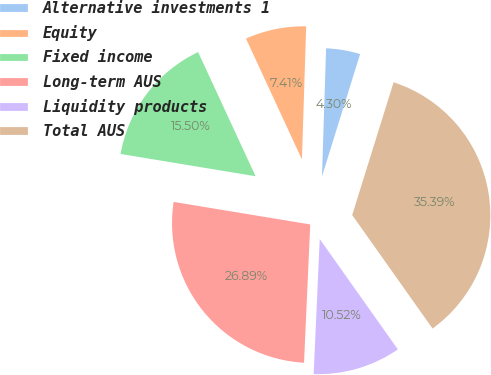Convert chart to OTSL. <chart><loc_0><loc_0><loc_500><loc_500><pie_chart><fcel>Alternative investments 1<fcel>Equity<fcel>Fixed income<fcel>Long-term AUS<fcel>Liquidity products<fcel>Total AUS<nl><fcel>4.3%<fcel>7.41%<fcel>15.5%<fcel>26.89%<fcel>10.52%<fcel>35.39%<nl></chart> 